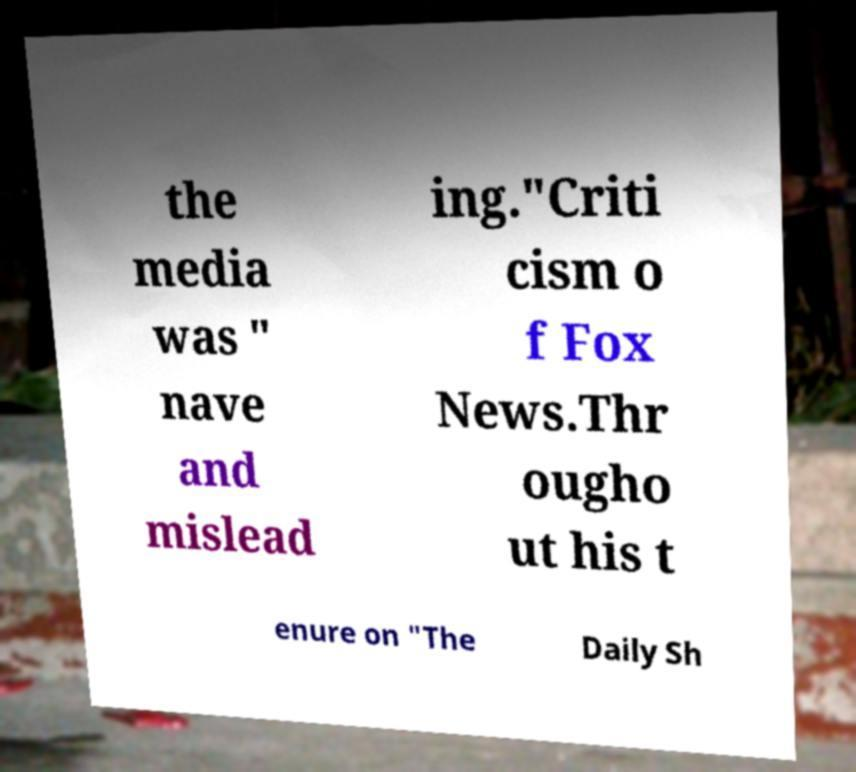Please identify and transcribe the text found in this image. the media was " nave and mislead ing."Criti cism o f Fox News.Thr ougho ut his t enure on "The Daily Sh 